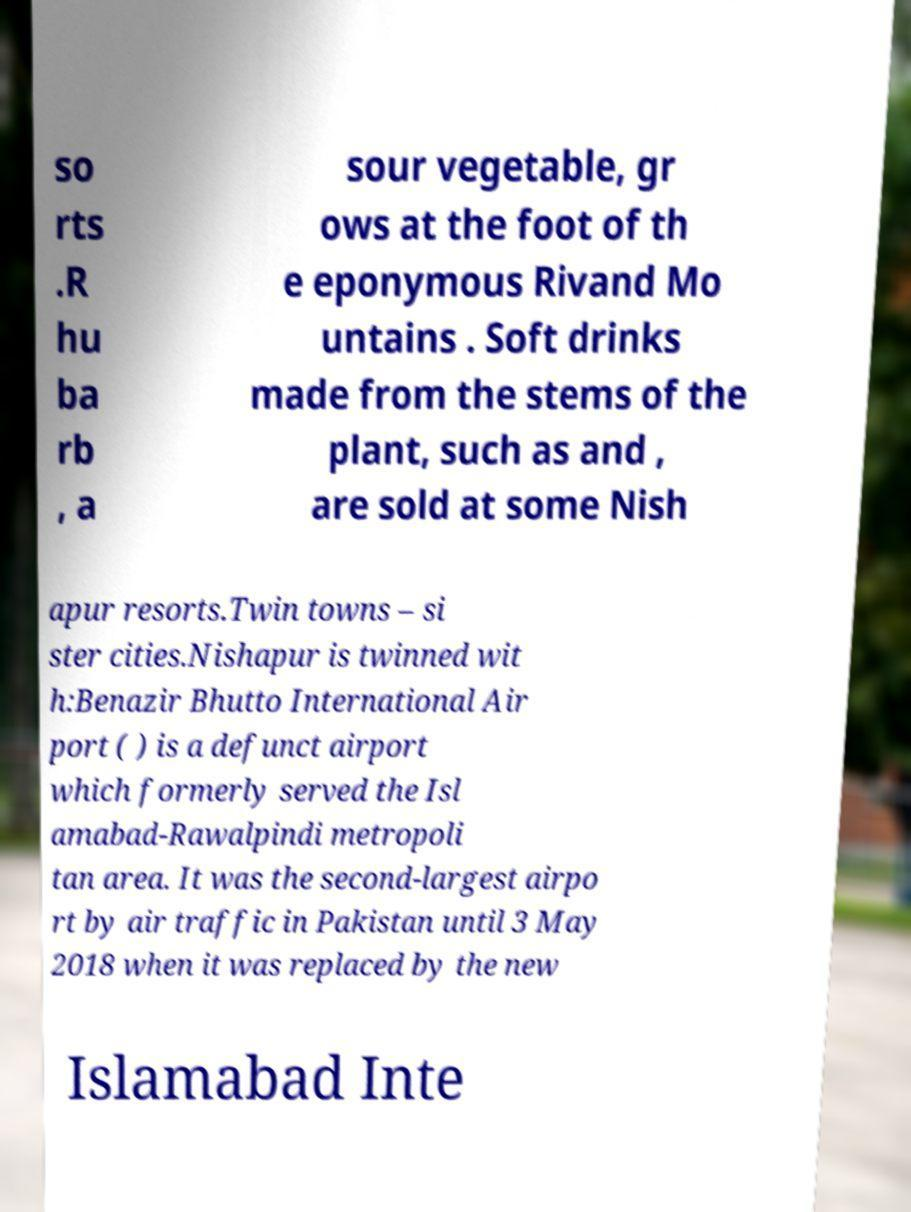I need the written content from this picture converted into text. Can you do that? so rts .R hu ba rb , a sour vegetable, gr ows at the foot of th e eponymous Rivand Mo untains . Soft drinks made from the stems of the plant, such as and , are sold at some Nish apur resorts.Twin towns – si ster cities.Nishapur is twinned wit h:Benazir Bhutto International Air port ( ) is a defunct airport which formerly served the Isl amabad-Rawalpindi metropoli tan area. It was the second-largest airpo rt by air traffic in Pakistan until 3 May 2018 when it was replaced by the new Islamabad Inte 